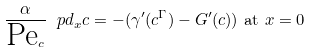Convert formula to latex. <formula><loc_0><loc_0><loc_500><loc_500>\frac { \alpha } { \text {Pe} _ { c } } \ p d _ { x } c = - ( \gamma ^ { \prime } ( c ^ { \Gamma } ) - G ^ { \prime } ( c ) ) & \text { at } x = 0</formula> 